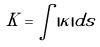<formula> <loc_0><loc_0><loc_500><loc_500>K = \int | \kappa | d s</formula> 